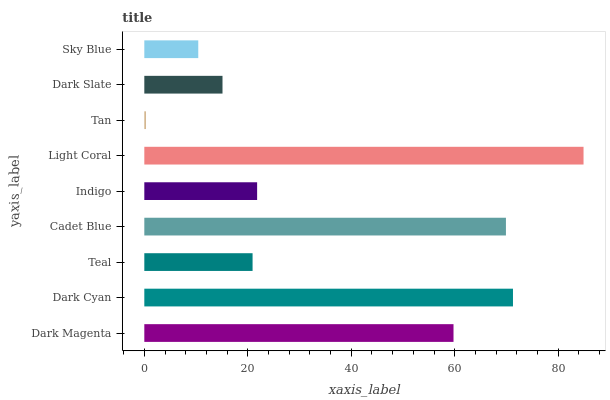Is Tan the minimum?
Answer yes or no. Yes. Is Light Coral the maximum?
Answer yes or no. Yes. Is Dark Cyan the minimum?
Answer yes or no. No. Is Dark Cyan the maximum?
Answer yes or no. No. Is Dark Cyan greater than Dark Magenta?
Answer yes or no. Yes. Is Dark Magenta less than Dark Cyan?
Answer yes or no. Yes. Is Dark Magenta greater than Dark Cyan?
Answer yes or no. No. Is Dark Cyan less than Dark Magenta?
Answer yes or no. No. Is Indigo the high median?
Answer yes or no. Yes. Is Indigo the low median?
Answer yes or no. Yes. Is Teal the high median?
Answer yes or no. No. Is Dark Magenta the low median?
Answer yes or no. No. 